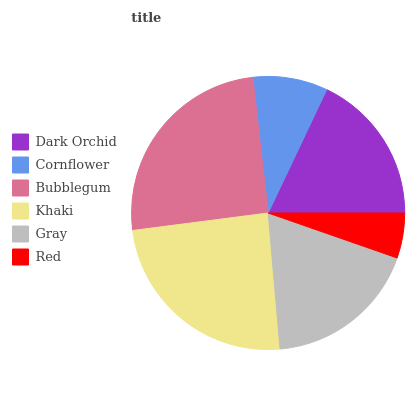Is Red the minimum?
Answer yes or no. Yes. Is Bubblegum the maximum?
Answer yes or no. Yes. Is Cornflower the minimum?
Answer yes or no. No. Is Cornflower the maximum?
Answer yes or no. No. Is Dark Orchid greater than Cornflower?
Answer yes or no. Yes. Is Cornflower less than Dark Orchid?
Answer yes or no. Yes. Is Cornflower greater than Dark Orchid?
Answer yes or no. No. Is Dark Orchid less than Cornflower?
Answer yes or no. No. Is Gray the high median?
Answer yes or no. Yes. Is Dark Orchid the low median?
Answer yes or no. Yes. Is Khaki the high median?
Answer yes or no. No. Is Khaki the low median?
Answer yes or no. No. 